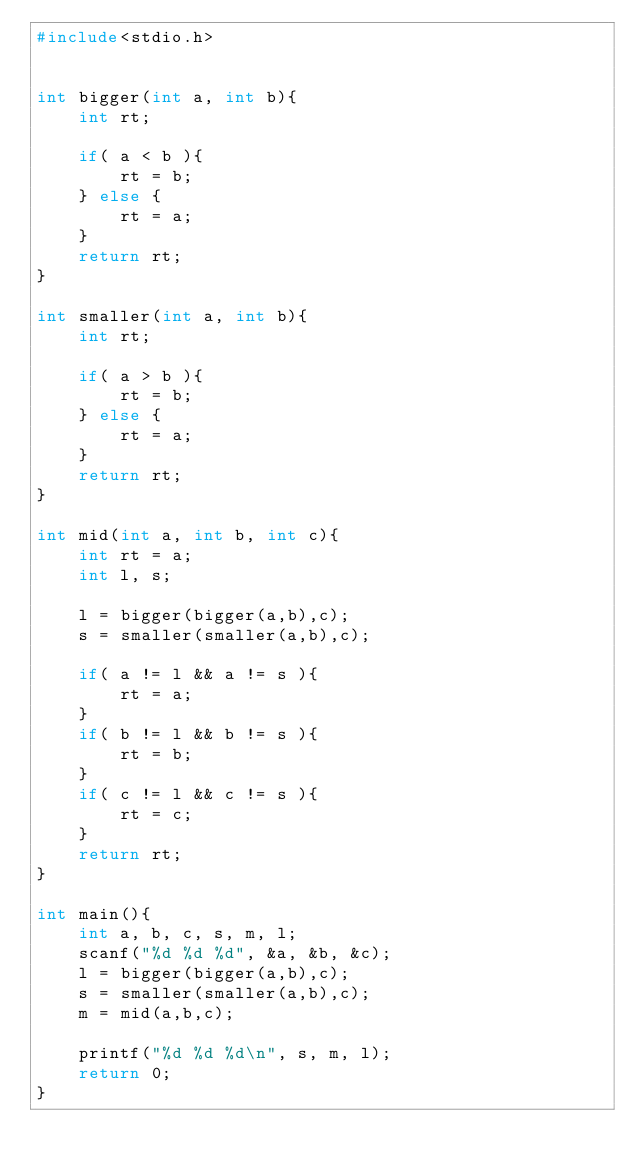Convert code to text. <code><loc_0><loc_0><loc_500><loc_500><_C_>#include<stdio.h>


int bigger(int a, int b){
    int rt;

    if( a < b ){
        rt = b;
    } else {
        rt = a;
    }
    return rt;
}

int smaller(int a, int b){
    int rt;

    if( a > b ){
        rt = b;
    } else {
        rt = a;
    }
    return rt;
}

int mid(int a, int b, int c){
    int rt = a;
    int l, s;

    l = bigger(bigger(a,b),c);
    s = smaller(smaller(a,b),c);

    if( a != l && a != s ){
        rt = a;
    }
    if( b != l && b != s ){
        rt = b;
    }
    if( c != l && c != s ){
        rt = c;
    }
    return rt;
}

int main(){
    int a, b, c, s, m, l;
    scanf("%d %d %d", &a, &b, &c);
    l = bigger(bigger(a,b),c);
    s = smaller(smaller(a,b),c);
    m = mid(a,b,c);
    
    printf("%d %d %d\n", s, m, l);
    return 0;
}
    
</code> 